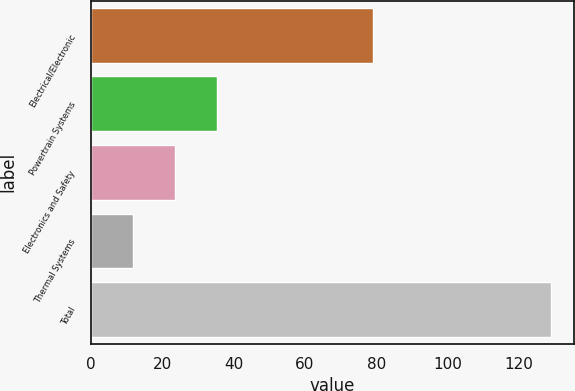Convert chart. <chart><loc_0><loc_0><loc_500><loc_500><bar_chart><fcel>Electrical/Electronic<fcel>Powertrain Systems<fcel>Electronics and Safety<fcel>Thermal Systems<fcel>Total<nl><fcel>79<fcel>35.4<fcel>23.7<fcel>12<fcel>129<nl></chart> 